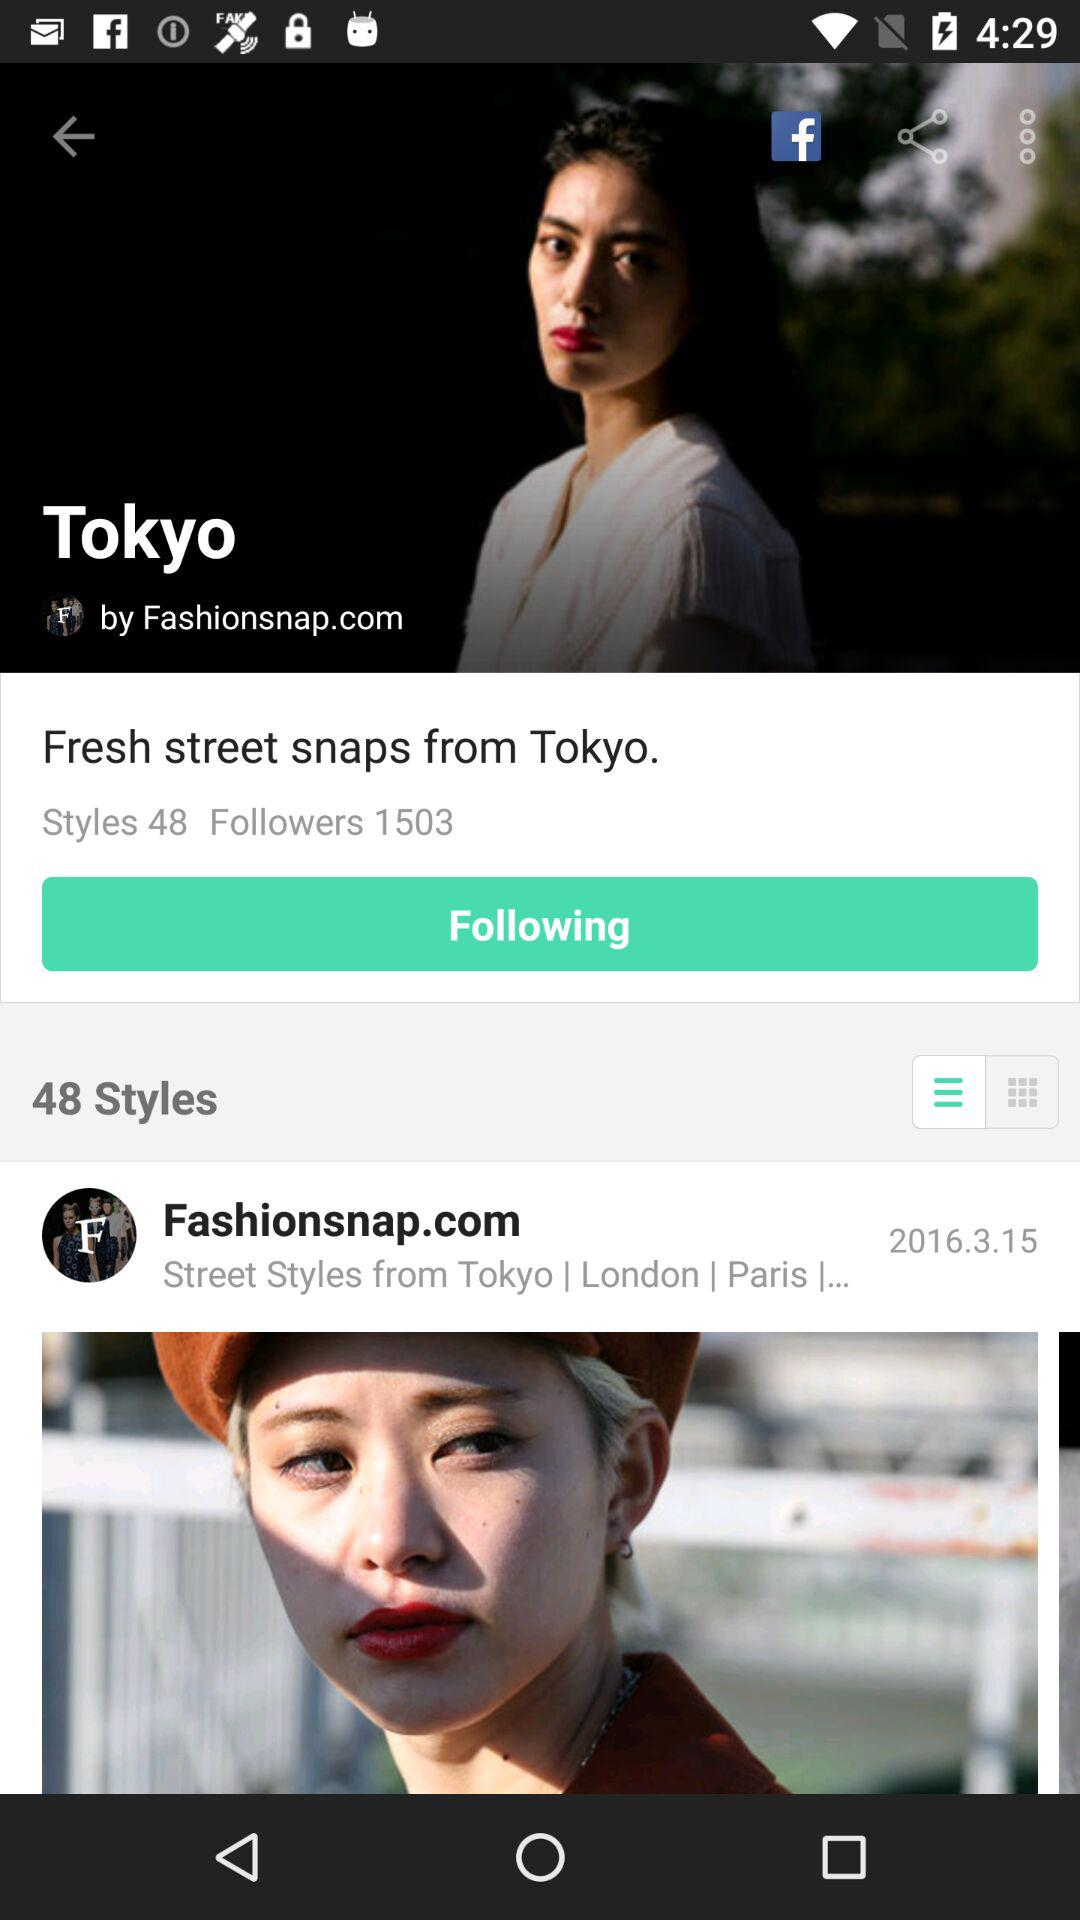When was the post by "Fashionsnap.com" updated? The post was updated on March 15, 2016. 